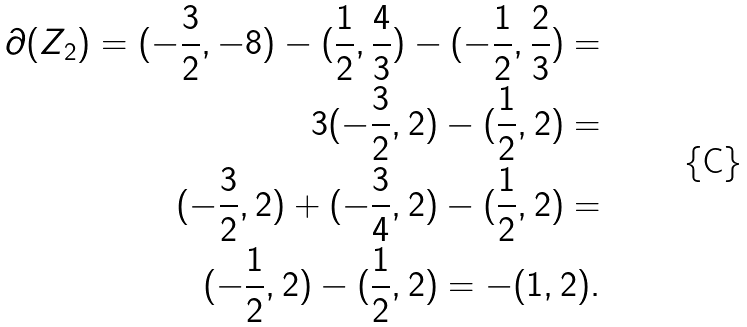Convert formula to latex. <formula><loc_0><loc_0><loc_500><loc_500>\partial ( Z _ { 2 } ) = ( - \frac { 3 } { 2 } , - 8 ) - ( \frac { 1 } { 2 } , \frac { 4 } { 3 } ) - ( - \frac { 1 } { 2 } , \frac { 2 } { 3 } ) = \\ 3 ( - \frac { 3 } { 2 } , 2 ) - ( \frac { 1 } { 2 } , 2 ) = \\ ( - \frac { 3 } { 2 } , 2 ) + ( - \frac { 3 } { 4 } , 2 ) - ( \frac { 1 } { 2 } , 2 ) = \\ ( - \frac { 1 } { 2 } , 2 ) - ( \frac { 1 } { 2 } , 2 ) = - ( 1 , 2 ) .</formula> 